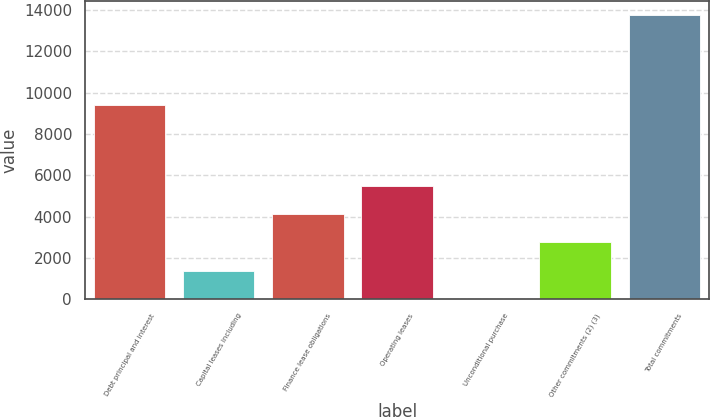<chart> <loc_0><loc_0><loc_500><loc_500><bar_chart><fcel>Debt principal and interest<fcel>Capital leases including<fcel>Finance lease obligations<fcel>Operating leases<fcel>Unconditional purchase<fcel>Other commitments (2) (3)<fcel>Total commitments<nl><fcel>9403<fcel>1377.5<fcel>4126.5<fcel>5501<fcel>3<fcel>2752<fcel>13748<nl></chart> 